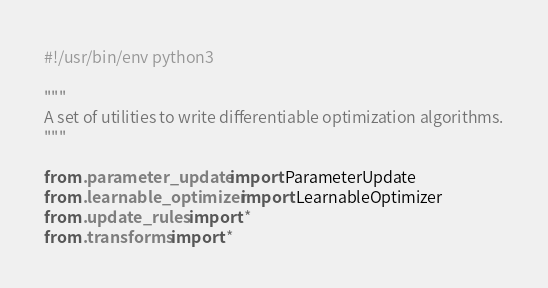<code> <loc_0><loc_0><loc_500><loc_500><_Python_>#!/usr/bin/env python3

"""
A set of utilities to write differentiable optimization algorithms.
"""

from .parameter_update import ParameterUpdate
from .learnable_optimizer import LearnableOptimizer
from .update_rules import *
from .transforms import *
</code> 